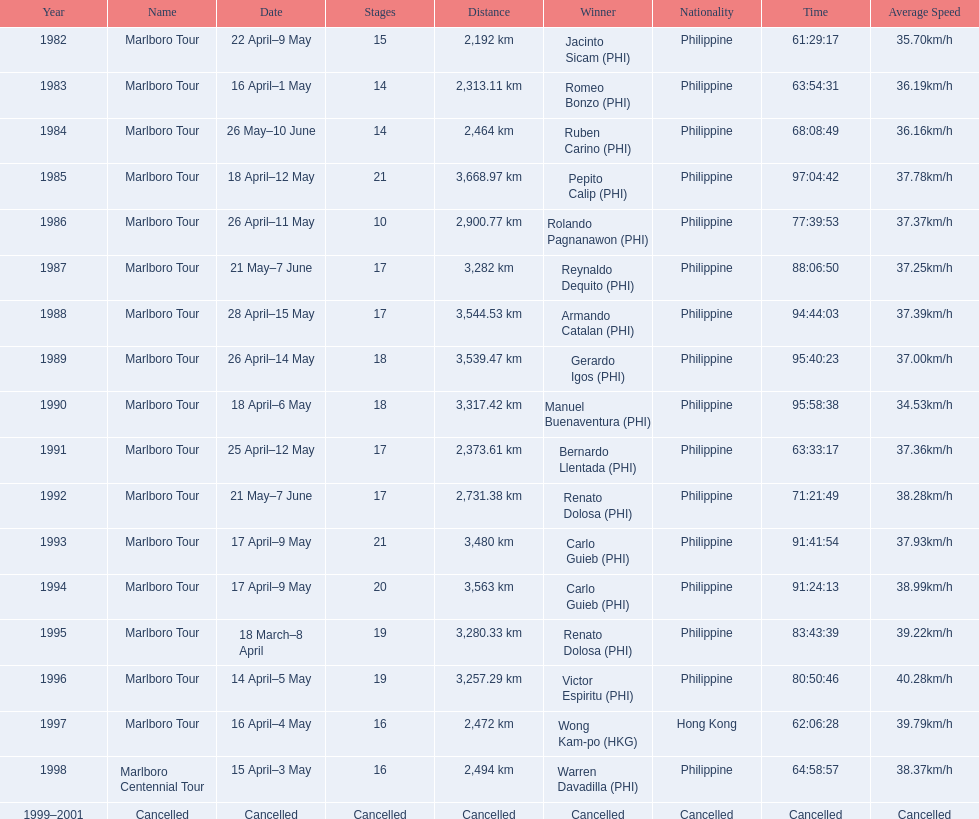Who were all of the winners? Jacinto Sicam (PHI), Romeo Bonzo (PHI), Ruben Carino (PHI), Pepito Calip (PHI), Rolando Pagnanawon (PHI), Reynaldo Dequito (PHI), Armando Catalan (PHI), Gerardo Igos (PHI), Manuel Buenaventura (PHI), Bernardo Llentada (PHI), Renato Dolosa (PHI), Carlo Guieb (PHI), Carlo Guieb (PHI), Renato Dolosa (PHI), Victor Espiritu (PHI), Wong Kam-po (HKG), Warren Davadilla (PHI), Cancelled. When did they compete? 1982, 1983, 1984, 1985, 1986, 1987, 1988, 1989, 1990, 1991, 1992, 1993, 1994, 1995, 1996, 1997, 1998, 1999–2001. What were their finishing times? 61:29:17, 63:54:31, 68:08:49, 97:04:42, 77:39:53, 88:06:50, 94:44:03, 95:40:23, 95:58:38, 63:33:17, 71:21:49, 91:41:54, 91:24:13, 83:43:39, 80:50:46, 62:06:28, 64:58:57, Cancelled. And who won during 1998? Warren Davadilla (PHI). What was his time? 64:58:57. 